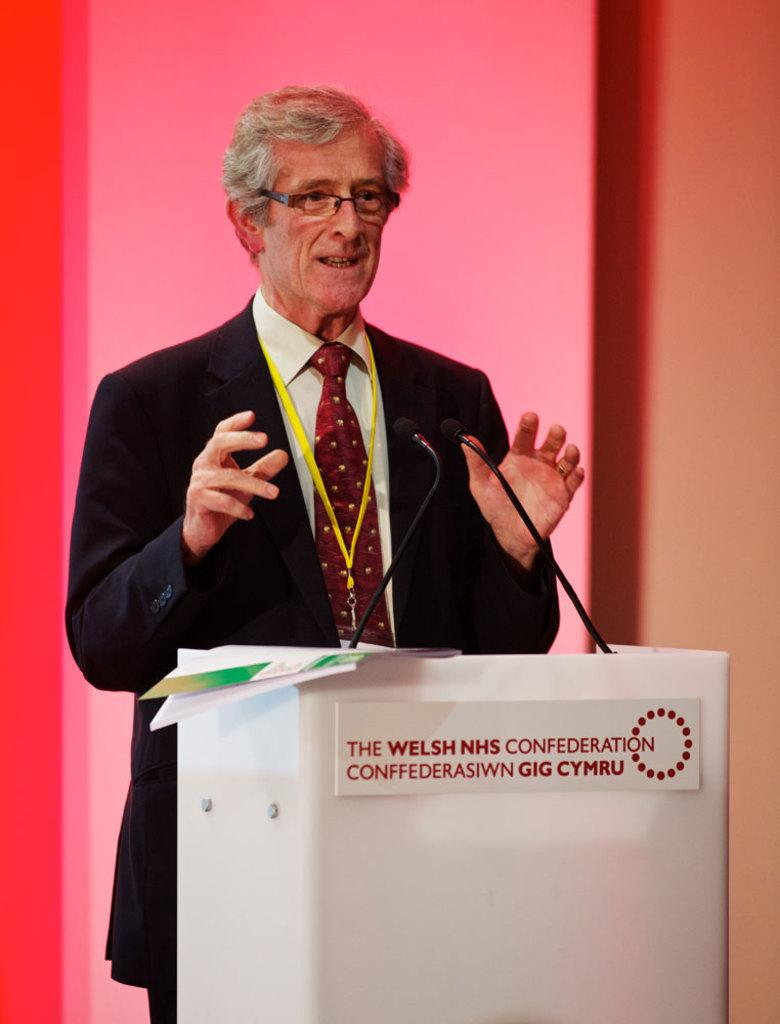What object is present in the image that is not a person? There is an old suit in the image. What is the old suit doing in the image? The old suit is talking on a mic. Where is the old suit standing in the image? The old suit is standing in front of a dias. What can be seen behind the old suit in the image? There is a wall visible in the background of the image. Can you see a rifle in the hands of the old suit in the image? There is no rifle present in the image; the old suit is talking on a mic. Who is the father of the old suit in the image? There is no information about the old suit's family in the image, so we cannot determine who their father is. 